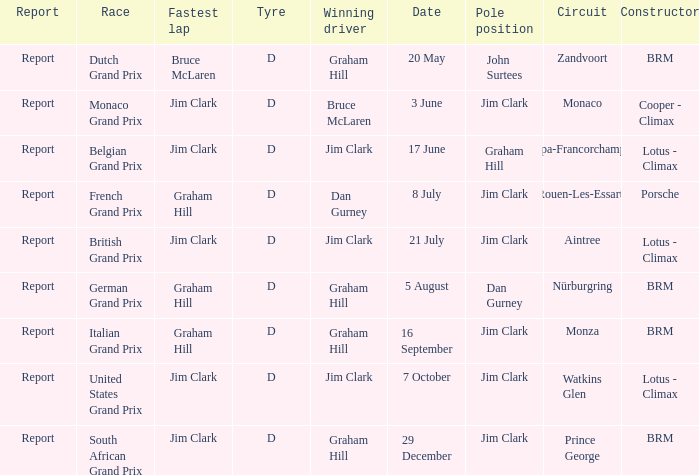What is the tyre on the race where Bruce Mclaren had the fastest lap? D. 